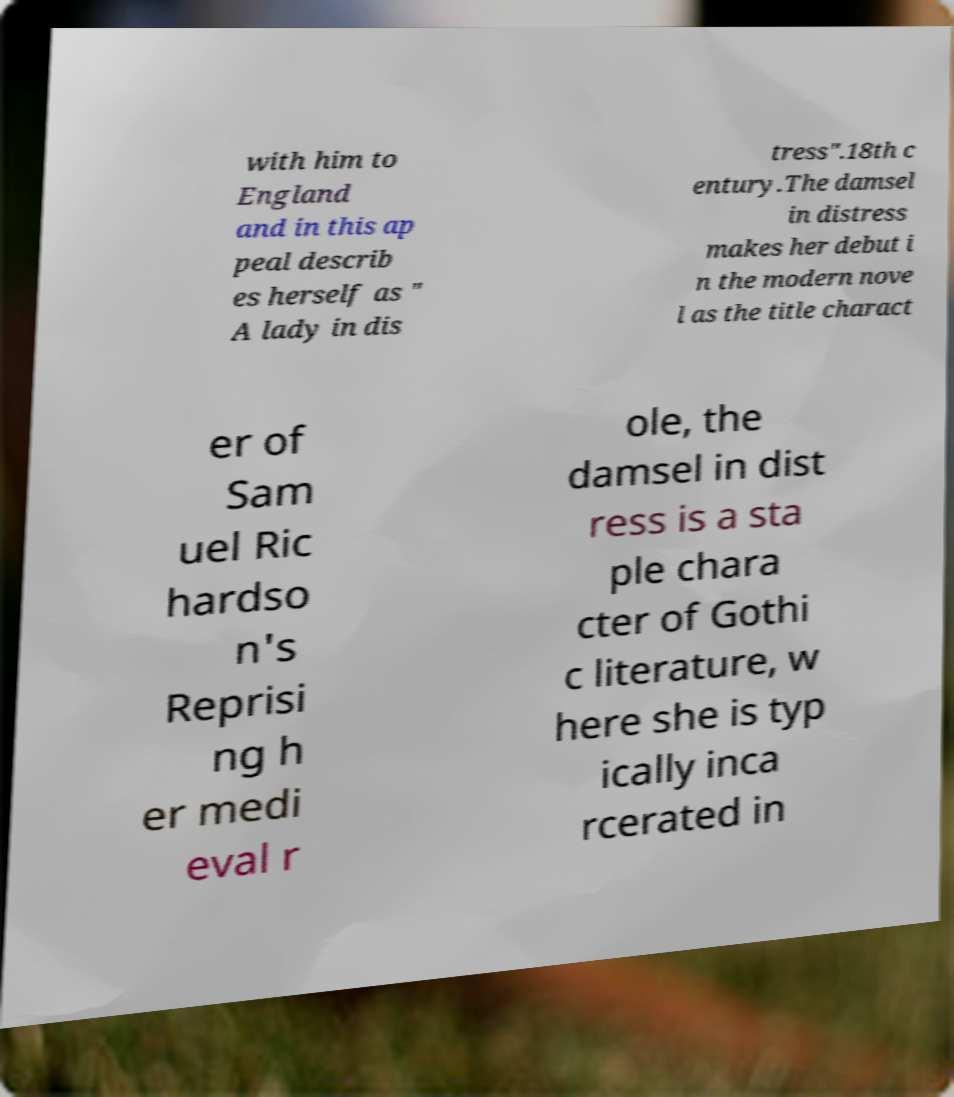I need the written content from this picture converted into text. Can you do that? with him to England and in this ap peal describ es herself as " A lady in dis tress".18th c entury.The damsel in distress makes her debut i n the modern nove l as the title charact er of Sam uel Ric hardso n's Reprisi ng h er medi eval r ole, the damsel in dist ress is a sta ple chara cter of Gothi c literature, w here she is typ ically inca rcerated in 